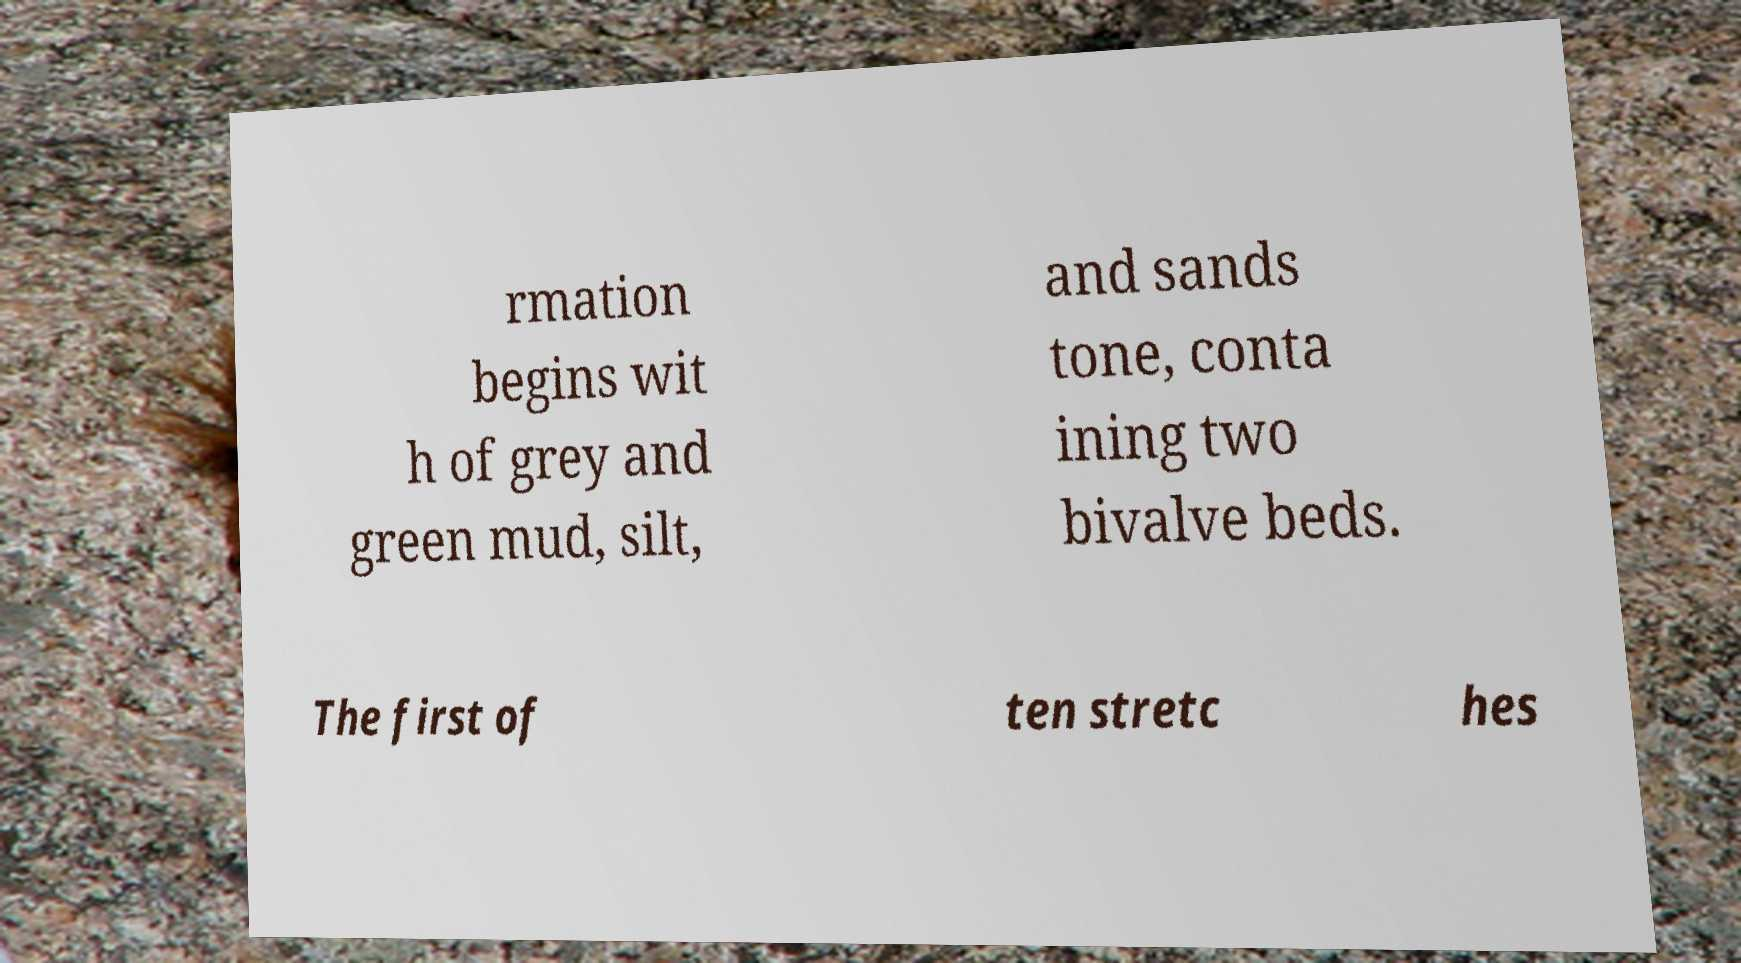There's text embedded in this image that I need extracted. Can you transcribe it verbatim? rmation begins wit h of grey and green mud, silt, and sands tone, conta ining two bivalve beds. The first of ten stretc hes 